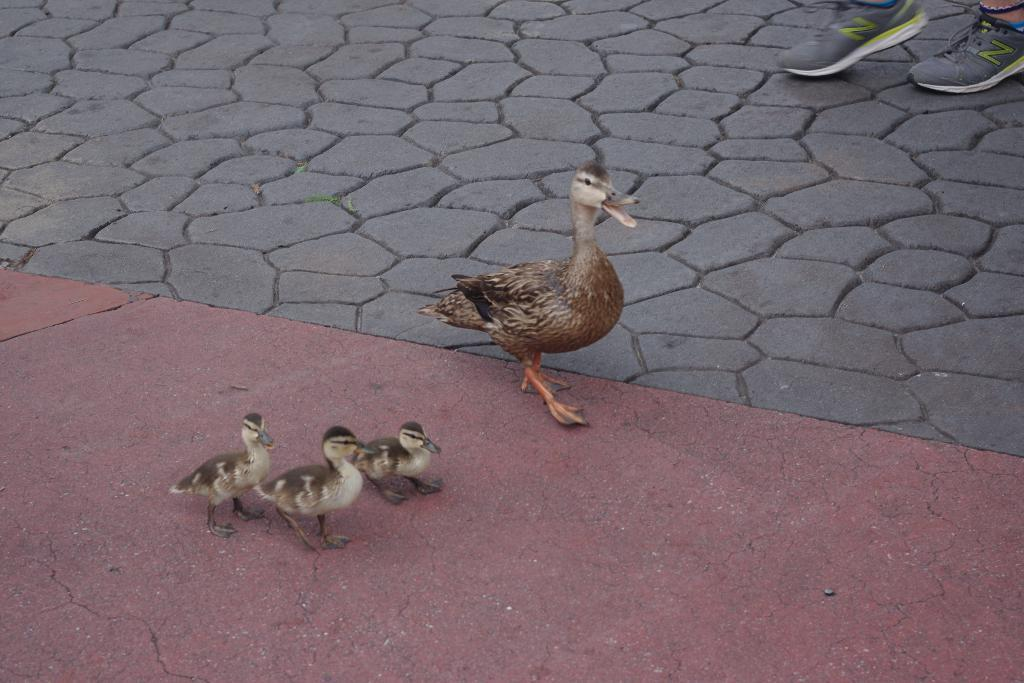How many ducks are present in the image? There are 4 ducks in the image. Can you describe anything related to a person in the image? Yes, there are legs of a person visible at the right back of the image. What type of footwear is the person wearing? The person is wearing shoes. What is the mind of the sun doing in the image? There is no sun or mind present in the image. Can you describe the behavior of the beast in the image? There is no beast present in the image. 